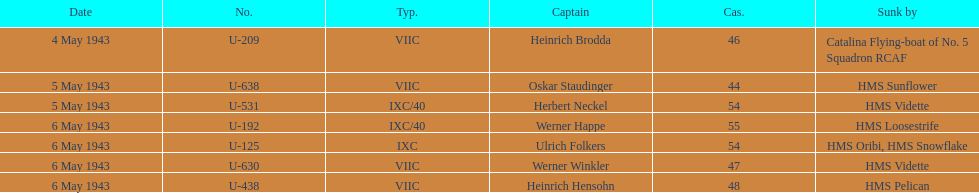Which underwater u-boat had the most significant loss of life? U-192. 